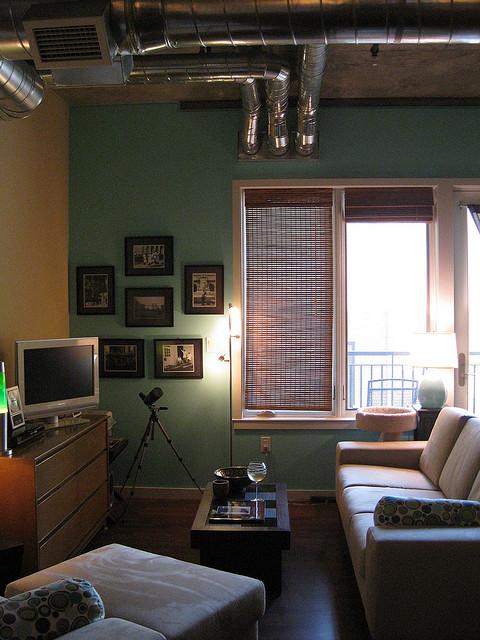Is that a bedroom?
Concise answer only. No. Is this a house or an apartment?
Quick response, please. Apartment. How many photos are on the wall?
Keep it brief. 6. 